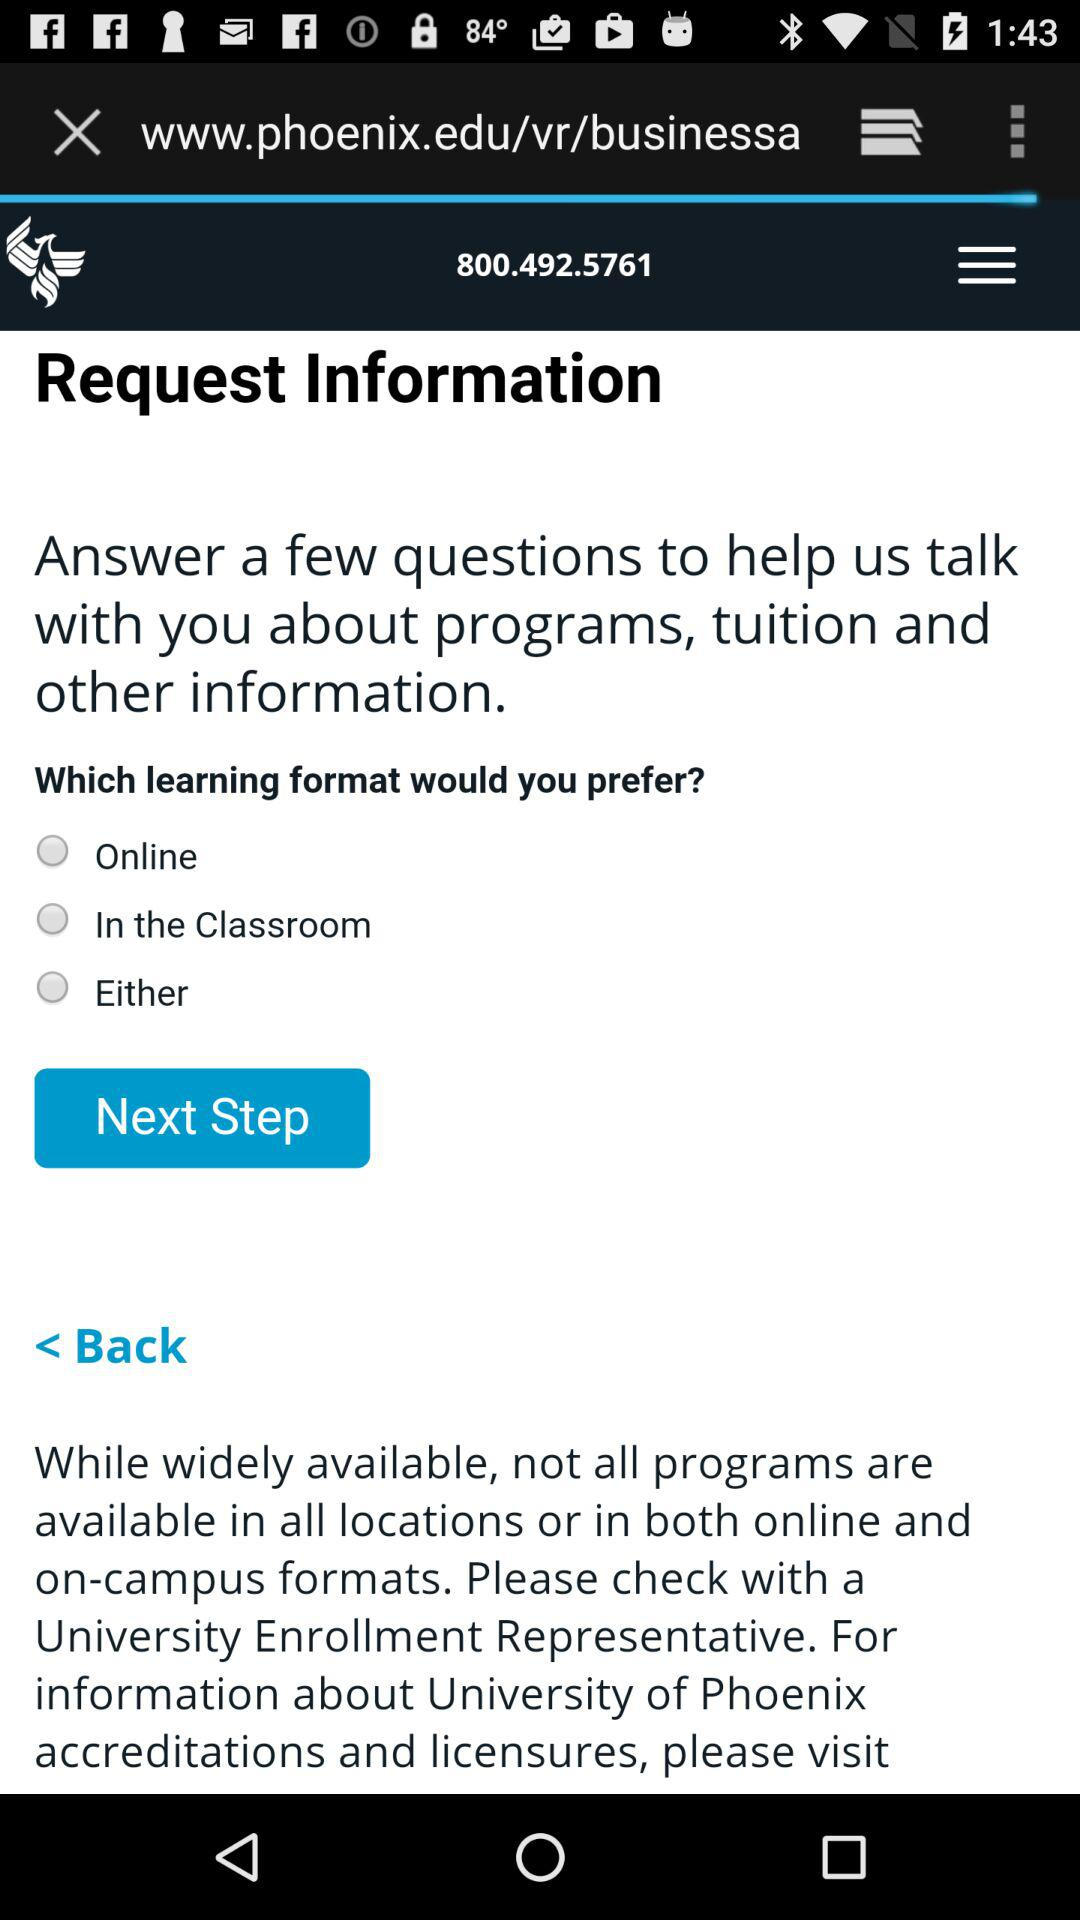What is the name of the university? The name of the university is "University of Phoenix". 